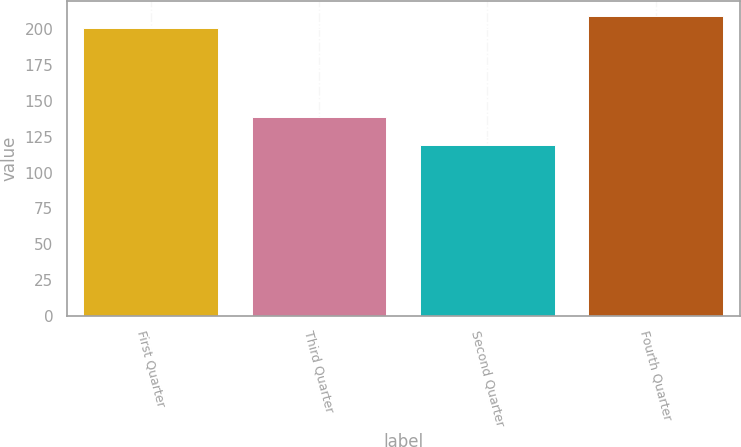Convert chart. <chart><loc_0><loc_0><loc_500><loc_500><bar_chart><fcel>First Quarter<fcel>Third Quarter<fcel>Second Quarter<fcel>Fourth Quarter<nl><fcel>200.56<fcel>138.42<fcel>119.12<fcel>209.25<nl></chart> 